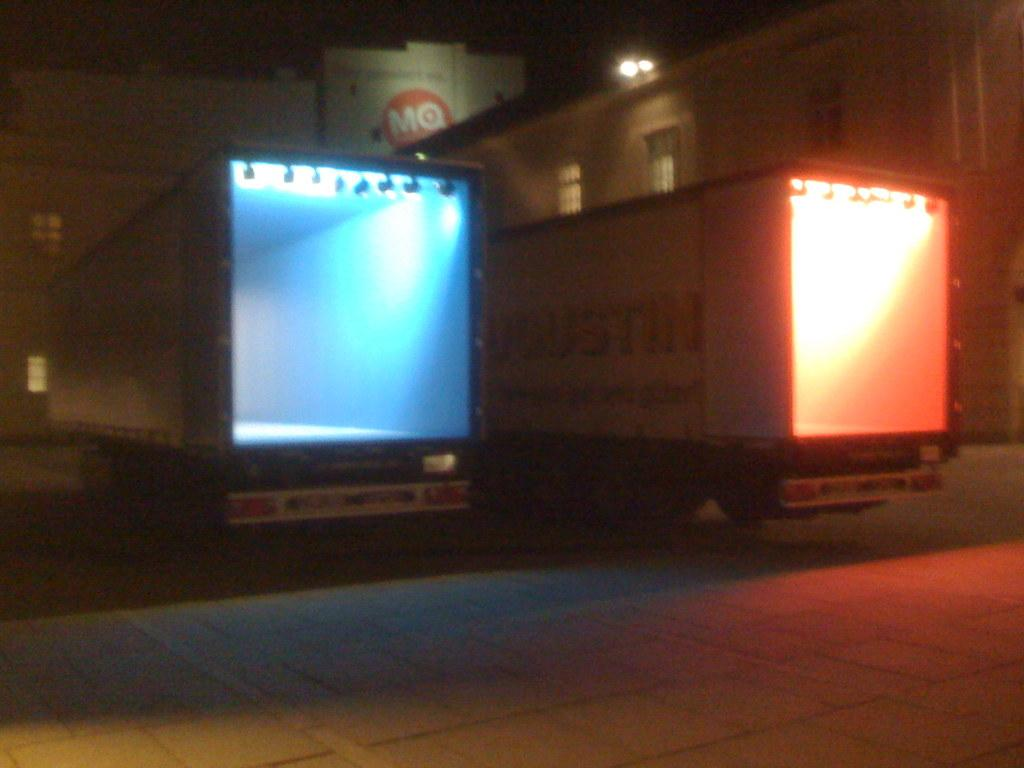<image>
Create a compact narrative representing the image presented. Two trailers with red and blue lights in front of an MQ building. 